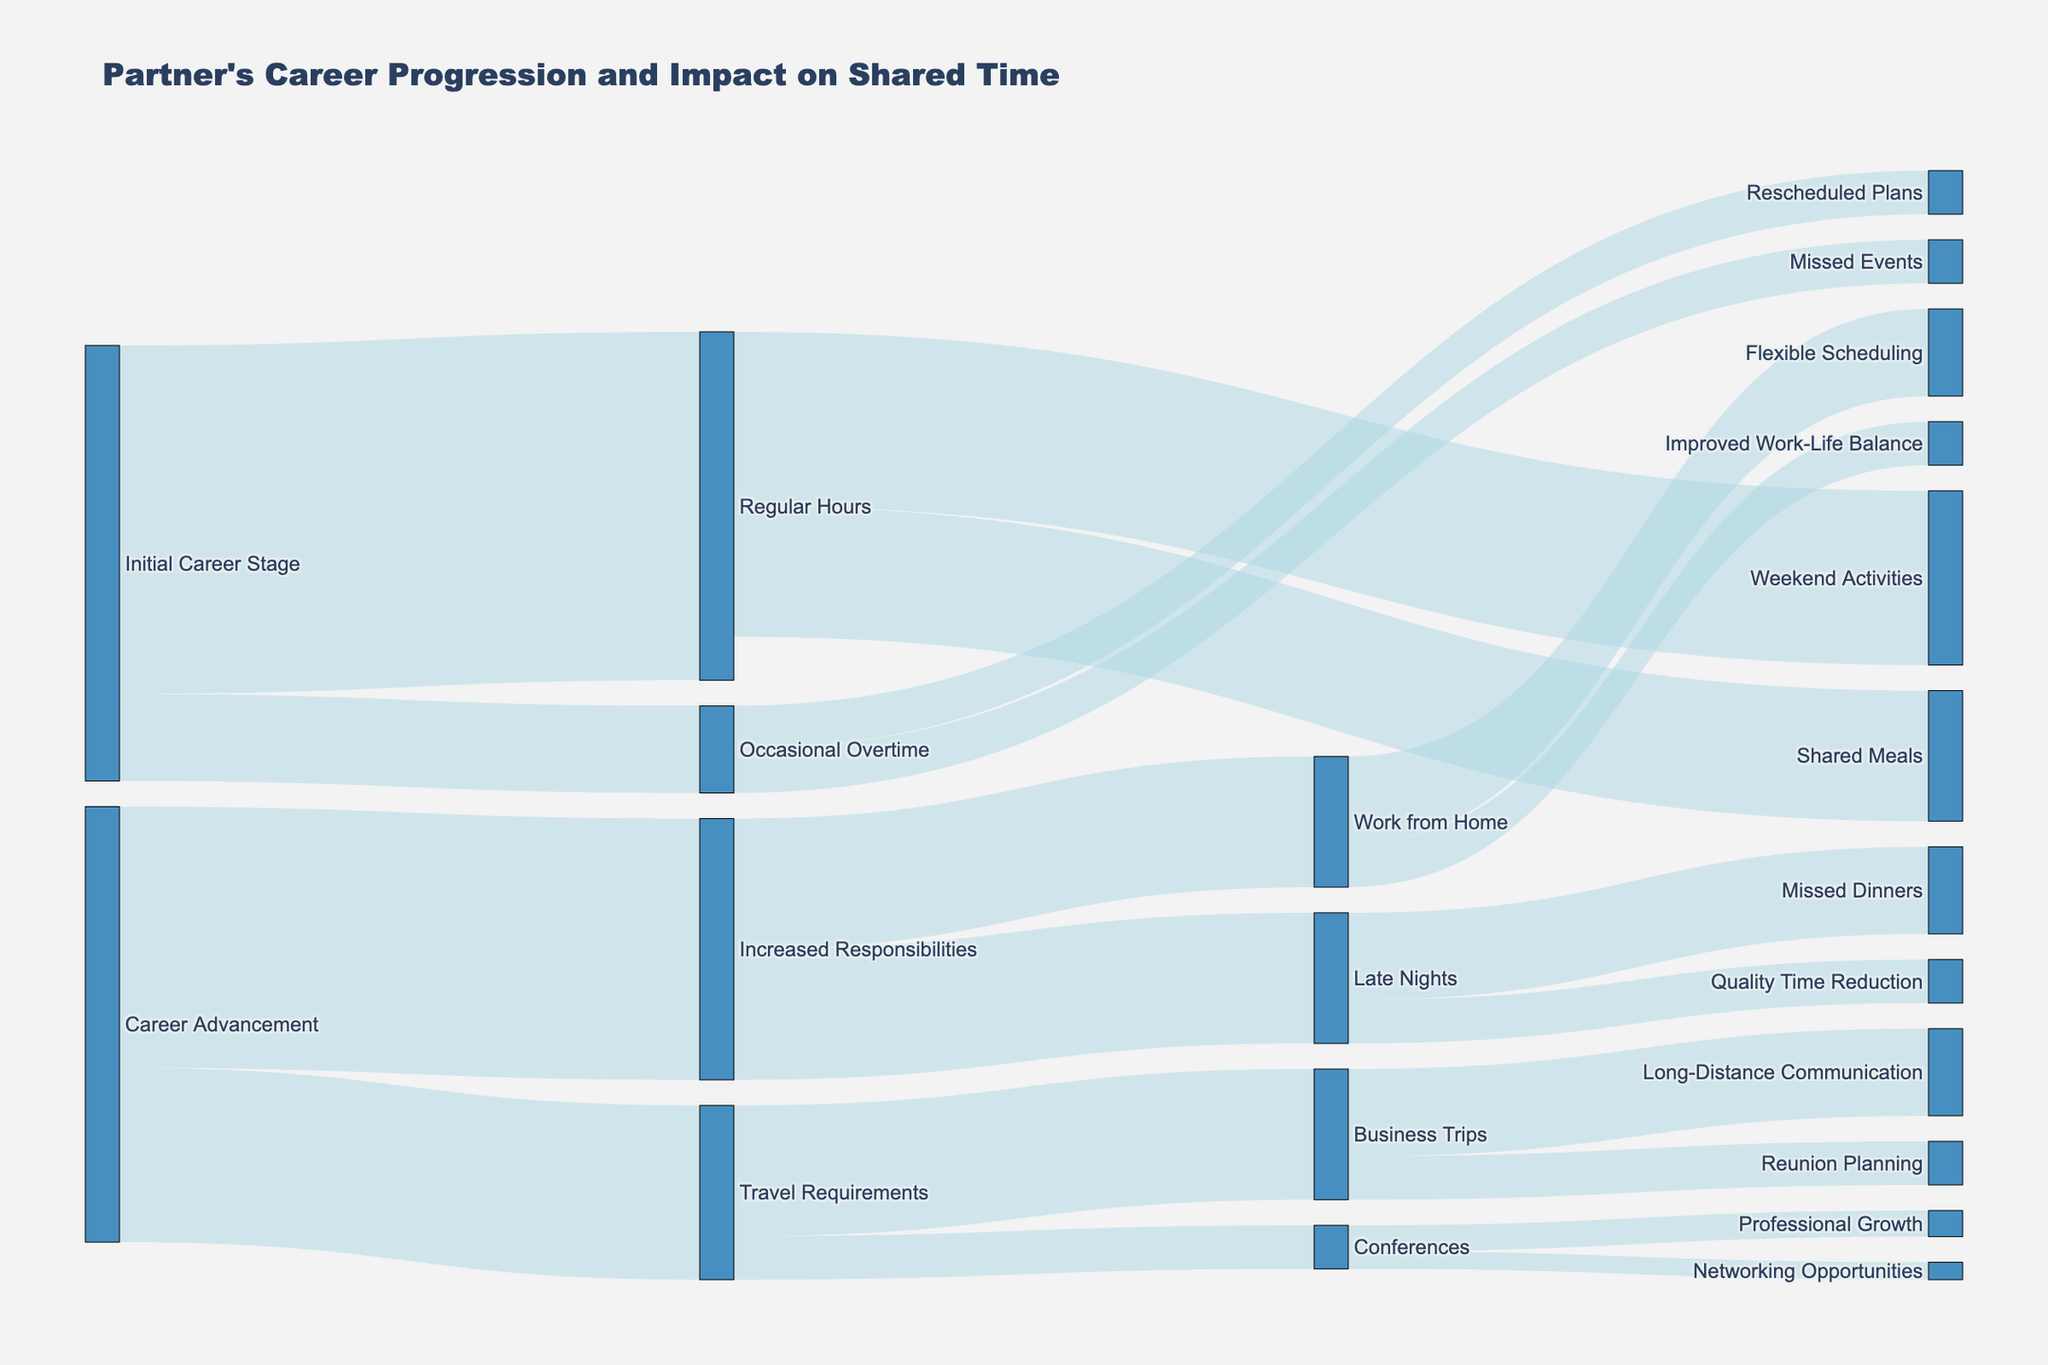What is the title of the Sankey diagram? The title of the diagram is displayed prominently at the top of the figure.
Answer: Partner's Career Progression and Impact on Shared Time What are the two main initial stages of the partner's career according to the diagram? The diagram shows the initial stages with their respective flows. There are two initial stages: "Initial Career Stage" and "Career Advancement."
Answer: Initial Career Stage, Career Advancement How much time is spent on Regular Hours in the Initial Career Stage? The diagram shows a flow from "Initial Career Stage" to "Regular Hours" with a value labeled next to it.
Answer: 40 What activities are labeled under Regular Hours, and how much time do they take? The diagram shows two flows originating from "Regular Hours" with values attached to them, indicating the activities and time.
Answer: Shared Meals (15), Weekend Activities (20) What is the combined value of time spent on activities under "Increased Responsibilities"? The diagram shows two flows from "Increased Responsibilities" with values, adding them gives the combined value.
Answer: 30 How does "Occasional Overtime" affect shared plans and events, and what is their total impact? The diagram shows flows from "Occasional Overtime" to "Missed Events" and "Rescheduled Plans" with values. Add these values for total impact.
Answer: Occasional Overtime affects "Missed Events" (5) and "Rescheduled Plans" (5), with a total impact of 10 Which career stage contributes to "Late Nights," and what is the total value of Late Nights? The diagram shows a flow from "Increased Responsibilities" to "Late Nights" with a value, indicated by the total under "Late Nights."
Answer: Career Advancement, 15 What secondary effects do "Late Nights" lead to, and what is their combined impact? The diagram shows flows from "Late Nights" to other nodes with values next to them, indicating the secondary effects. Add these values for the combined impact.
Answer: Missed Dinners (10), Quality Time Reduction (5), combined impact is 15 What is the total value for changes impacting "Missed Events" and "Missed Dinners"? The diagram shows values for "Missed Events" and "Missed Dinners" from respective stages. Sum these values to get the total.
Answer: Missed Events (5) + Missed Dinners (10) = 15 